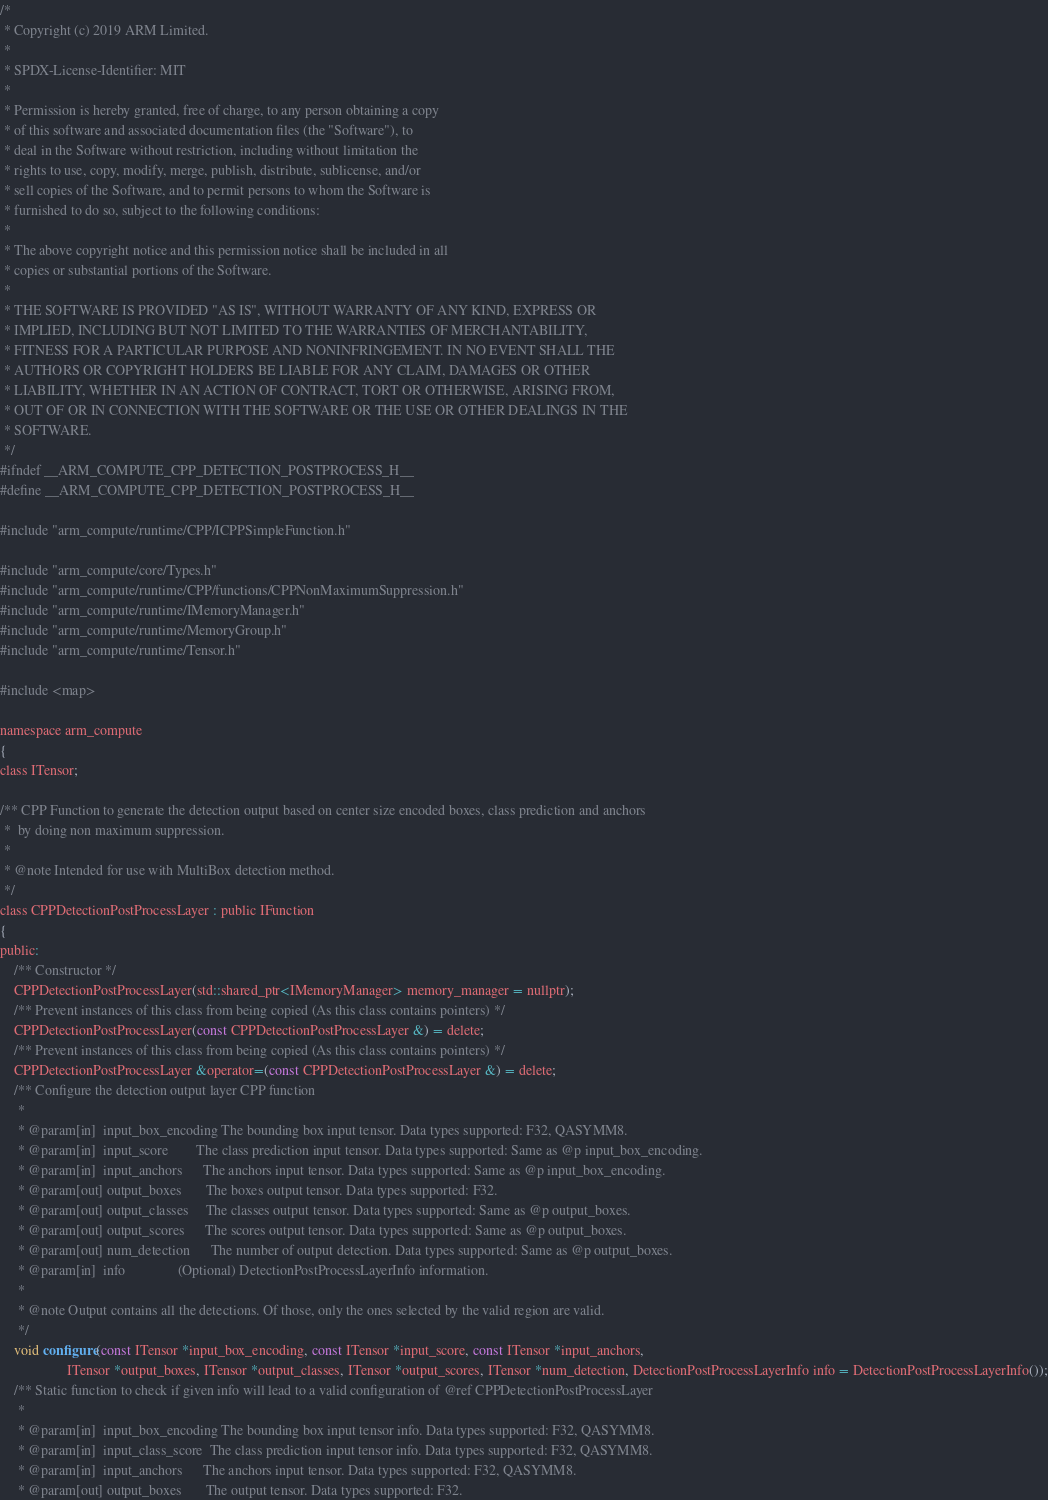<code> <loc_0><loc_0><loc_500><loc_500><_C_>/*
 * Copyright (c) 2019 ARM Limited.
 *
 * SPDX-License-Identifier: MIT
 *
 * Permission is hereby granted, free of charge, to any person obtaining a copy
 * of this software and associated documentation files (the "Software"), to
 * deal in the Software without restriction, including without limitation the
 * rights to use, copy, modify, merge, publish, distribute, sublicense, and/or
 * sell copies of the Software, and to permit persons to whom the Software is
 * furnished to do so, subject to the following conditions:
 *
 * The above copyright notice and this permission notice shall be included in all
 * copies or substantial portions of the Software.
 *
 * THE SOFTWARE IS PROVIDED "AS IS", WITHOUT WARRANTY OF ANY KIND, EXPRESS OR
 * IMPLIED, INCLUDING BUT NOT LIMITED TO THE WARRANTIES OF MERCHANTABILITY,
 * FITNESS FOR A PARTICULAR PURPOSE AND NONINFRINGEMENT. IN NO EVENT SHALL THE
 * AUTHORS OR COPYRIGHT HOLDERS BE LIABLE FOR ANY CLAIM, DAMAGES OR OTHER
 * LIABILITY, WHETHER IN AN ACTION OF CONTRACT, TORT OR OTHERWISE, ARISING FROM,
 * OUT OF OR IN CONNECTION WITH THE SOFTWARE OR THE USE OR OTHER DEALINGS IN THE
 * SOFTWARE.
 */
#ifndef __ARM_COMPUTE_CPP_DETECTION_POSTPROCESS_H__
#define __ARM_COMPUTE_CPP_DETECTION_POSTPROCESS_H__

#include "arm_compute/runtime/CPP/ICPPSimpleFunction.h"

#include "arm_compute/core/Types.h"
#include "arm_compute/runtime/CPP/functions/CPPNonMaximumSuppression.h"
#include "arm_compute/runtime/IMemoryManager.h"
#include "arm_compute/runtime/MemoryGroup.h"
#include "arm_compute/runtime/Tensor.h"

#include <map>

namespace arm_compute
{
class ITensor;

/** CPP Function to generate the detection output based on center size encoded boxes, class prediction and anchors
 *  by doing non maximum suppression.
 *
 * @note Intended for use with MultiBox detection method.
 */
class CPPDetectionPostProcessLayer : public IFunction
{
public:
    /** Constructor */
    CPPDetectionPostProcessLayer(std::shared_ptr<IMemoryManager> memory_manager = nullptr);
    /** Prevent instances of this class from being copied (As this class contains pointers) */
    CPPDetectionPostProcessLayer(const CPPDetectionPostProcessLayer &) = delete;
    /** Prevent instances of this class from being copied (As this class contains pointers) */
    CPPDetectionPostProcessLayer &operator=(const CPPDetectionPostProcessLayer &) = delete;
    /** Configure the detection output layer CPP function
     *
     * @param[in]  input_box_encoding The bounding box input tensor. Data types supported: F32, QASYMM8.
     * @param[in]  input_score        The class prediction input tensor. Data types supported: Same as @p input_box_encoding.
     * @param[in]  input_anchors      The anchors input tensor. Data types supported: Same as @p input_box_encoding.
     * @param[out] output_boxes       The boxes output tensor. Data types supported: F32.
     * @param[out] output_classes     The classes output tensor. Data types supported: Same as @p output_boxes.
     * @param[out] output_scores      The scores output tensor. Data types supported: Same as @p output_boxes.
     * @param[out] num_detection      The number of output detection. Data types supported: Same as @p output_boxes.
     * @param[in]  info               (Optional) DetectionPostProcessLayerInfo information.
     *
     * @note Output contains all the detections. Of those, only the ones selected by the valid region are valid.
     */
    void configure(const ITensor *input_box_encoding, const ITensor *input_score, const ITensor *input_anchors,
                   ITensor *output_boxes, ITensor *output_classes, ITensor *output_scores, ITensor *num_detection, DetectionPostProcessLayerInfo info = DetectionPostProcessLayerInfo());
    /** Static function to check if given info will lead to a valid configuration of @ref CPPDetectionPostProcessLayer
     *
     * @param[in]  input_box_encoding The bounding box input tensor info. Data types supported: F32, QASYMM8.
     * @param[in]  input_class_score  The class prediction input tensor info. Data types supported: F32, QASYMM8.
     * @param[in]  input_anchors      The anchors input tensor. Data types supported: F32, QASYMM8.
     * @param[out] output_boxes       The output tensor. Data types supported: F32.</code> 